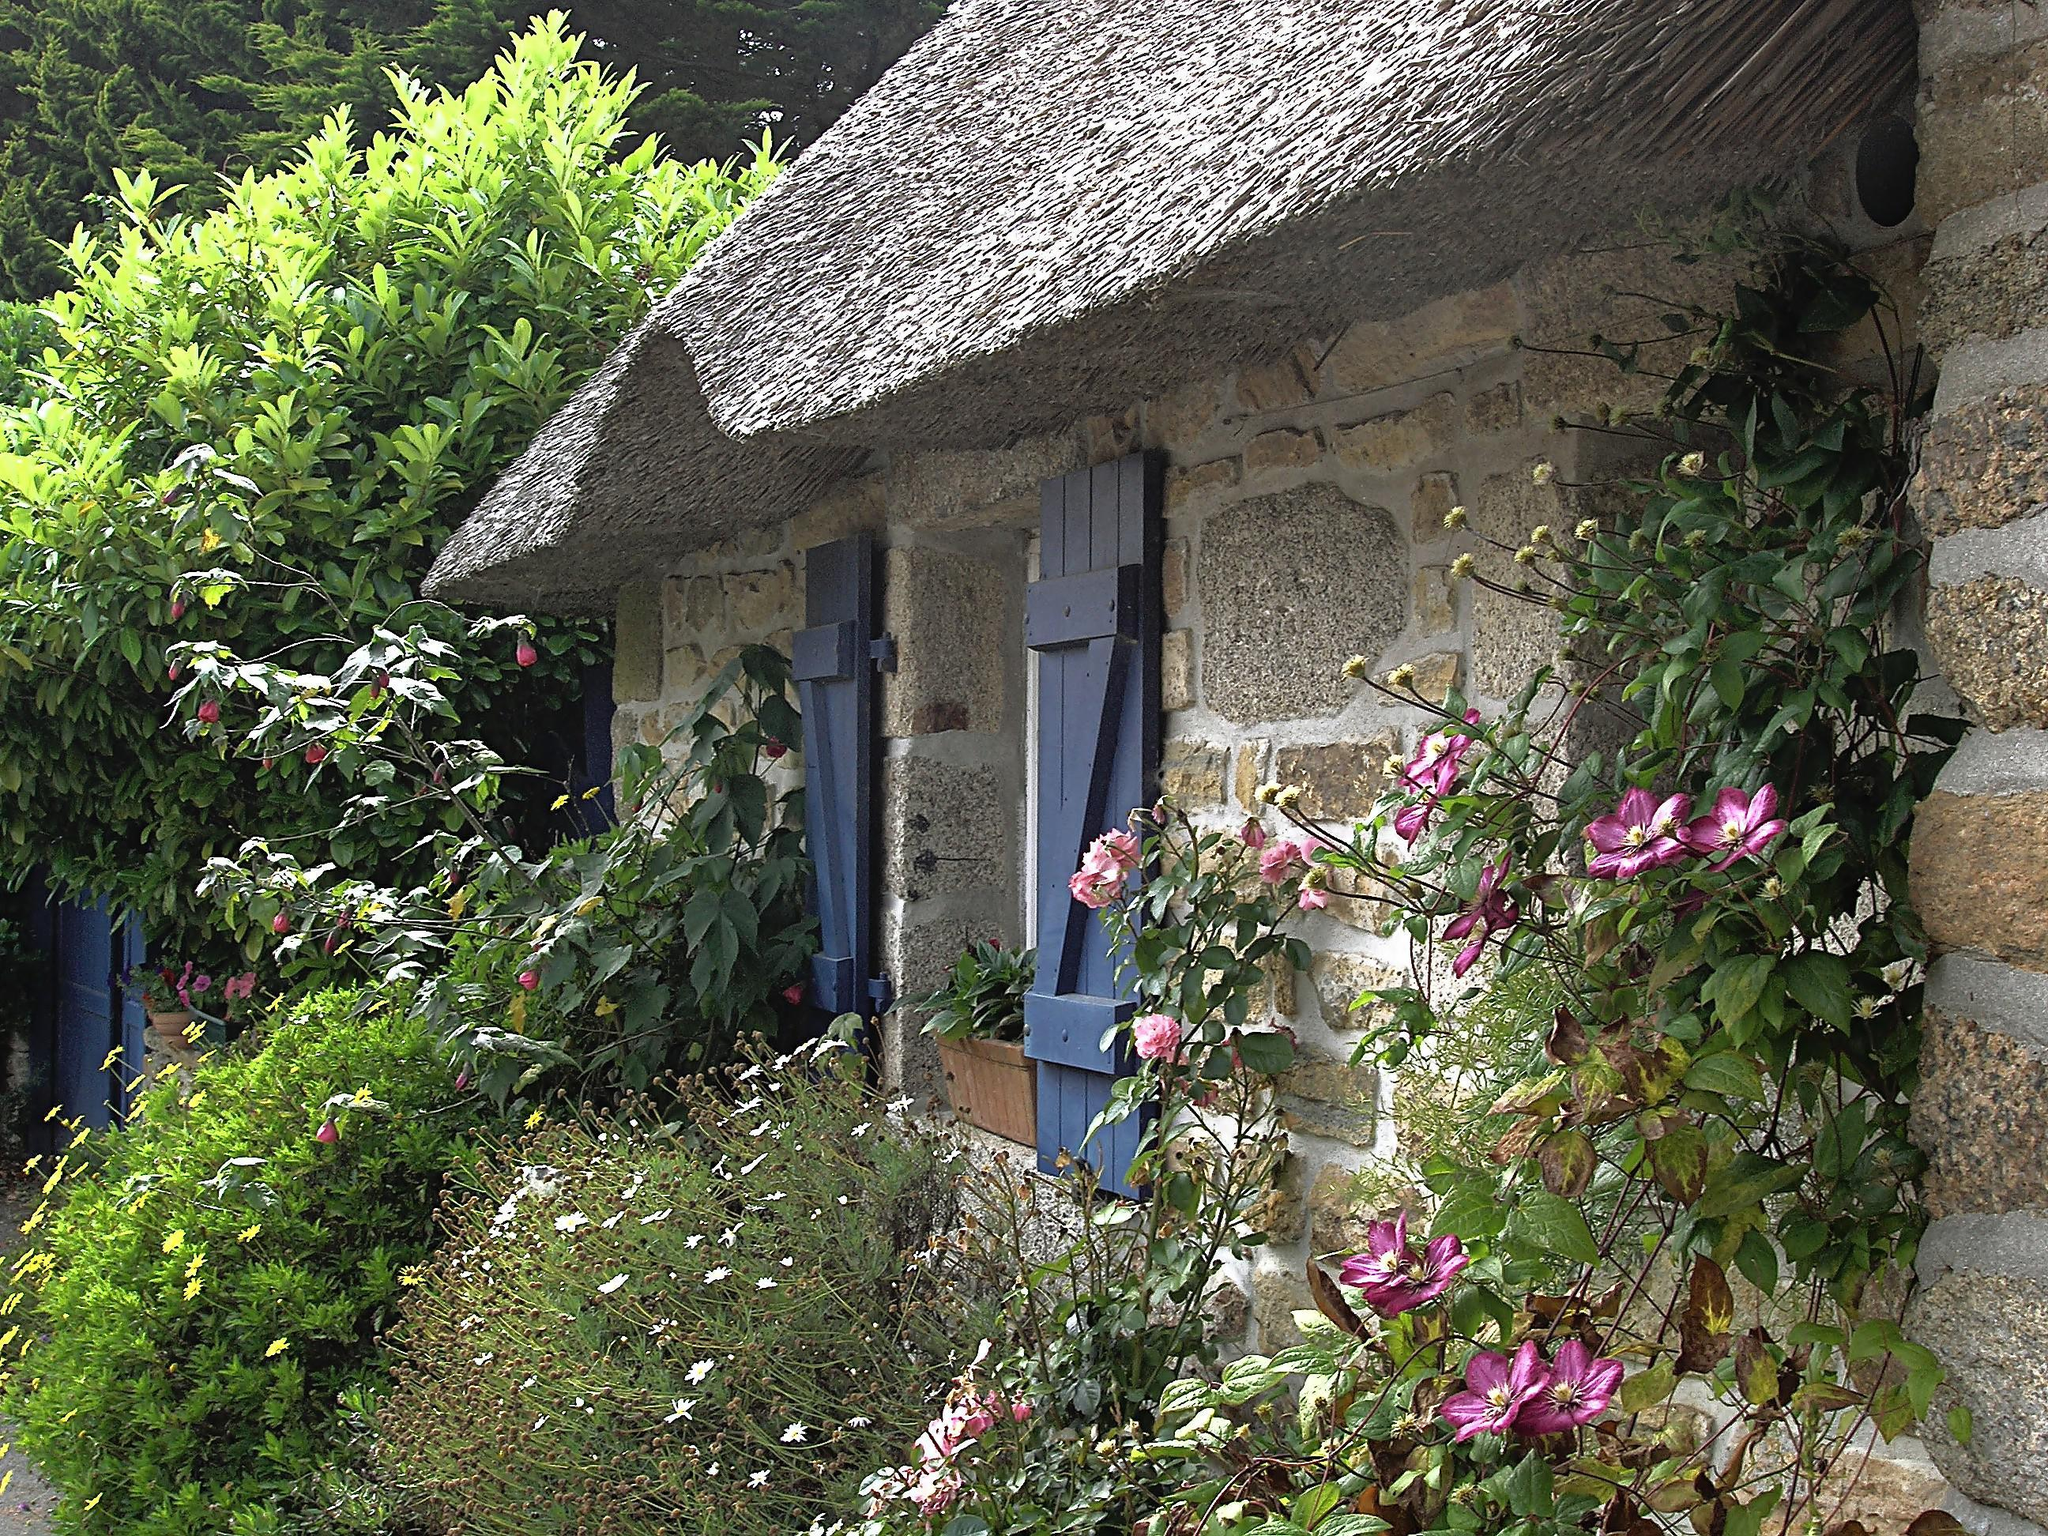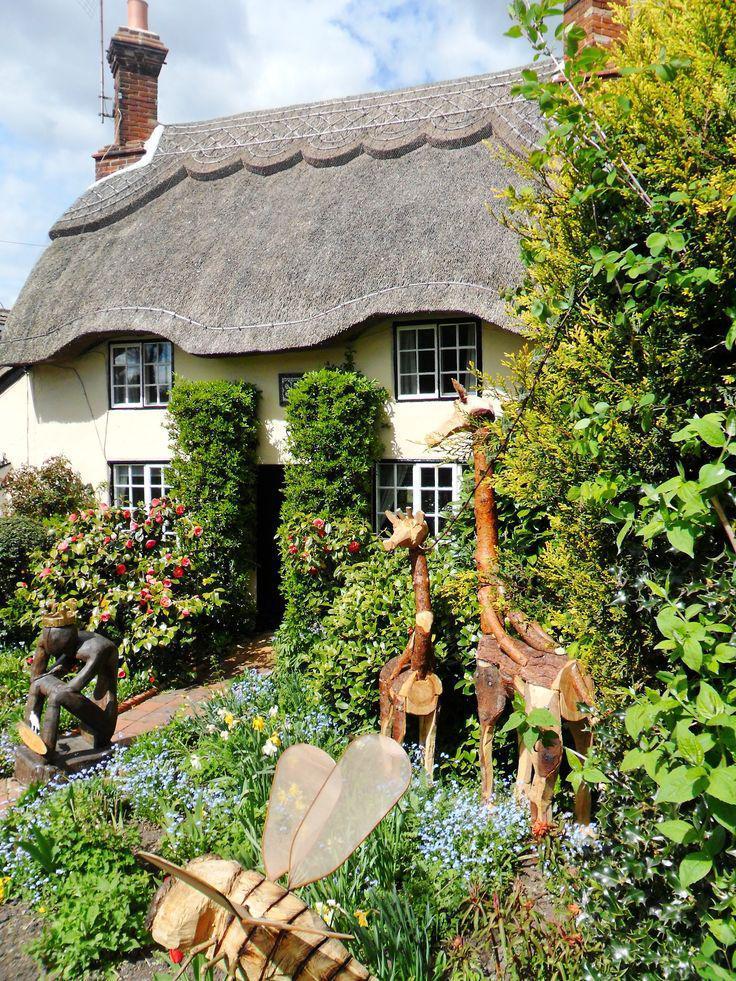The first image is the image on the left, the second image is the image on the right. Considering the images on both sides, is "At least one of the buildings has shutters around the windows." valid? Answer yes or no. Yes. The first image is the image on the left, the second image is the image on the right. Given the left and right images, does the statement "Each image shows one building with a thick textured roof and some flowers around it, and at least one of the roofs pictured curves around parts of the building." hold true? Answer yes or no. Yes. 